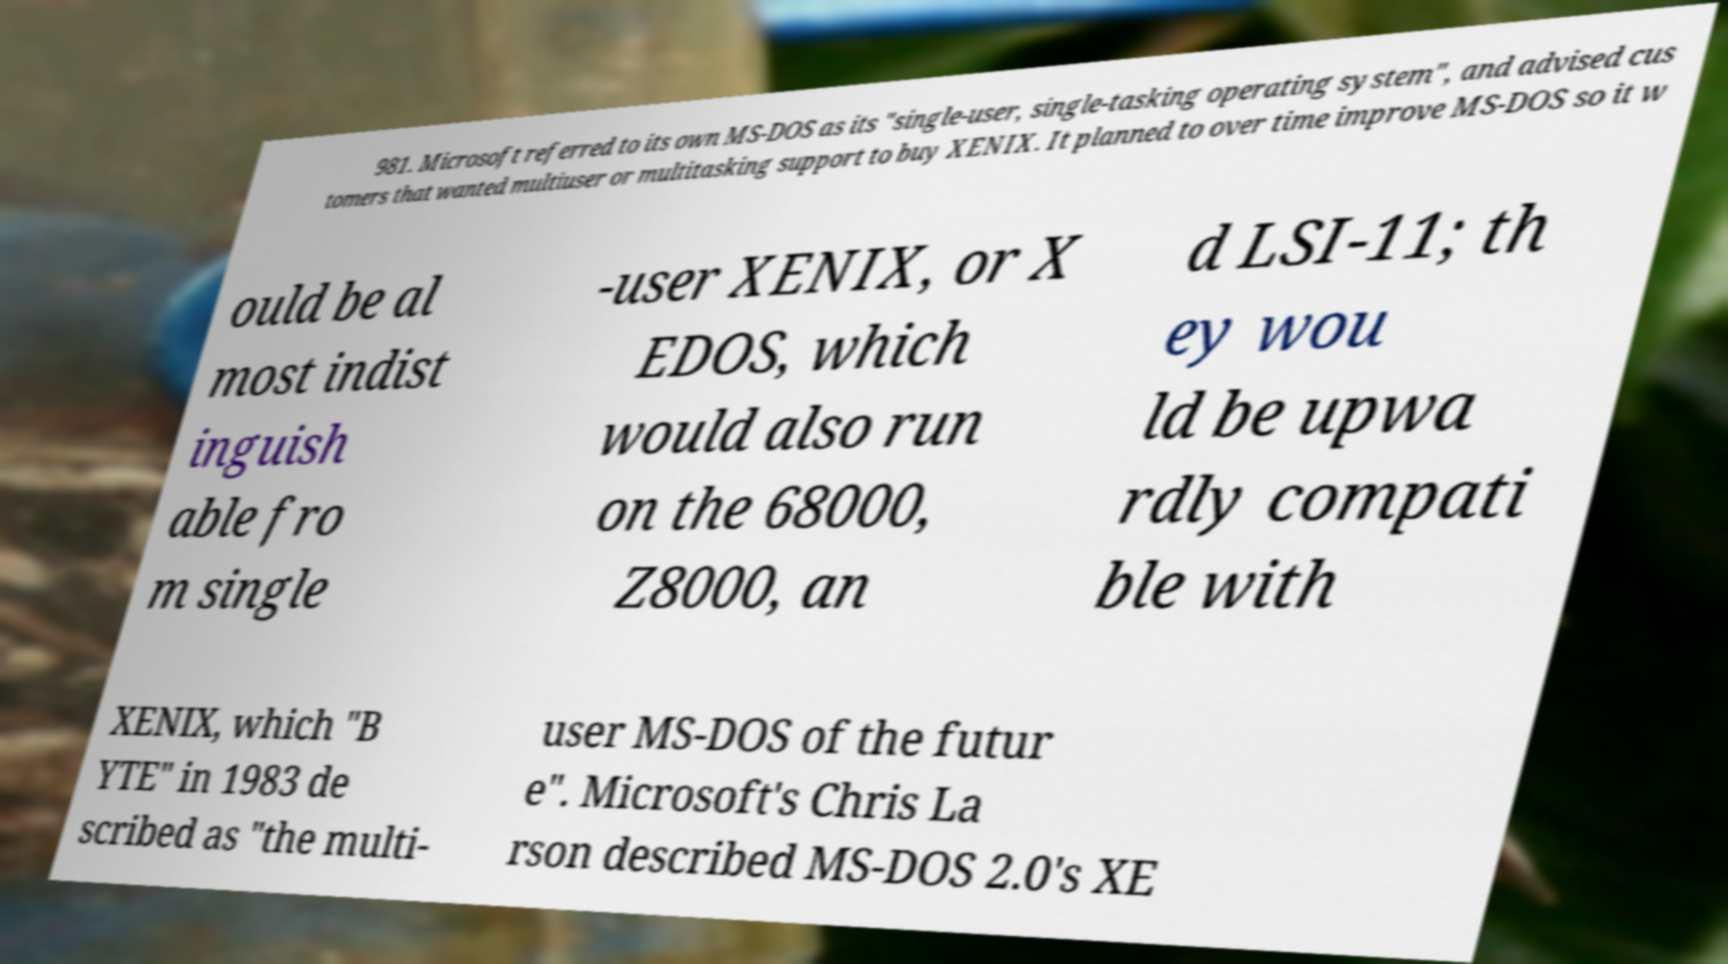There's text embedded in this image that I need extracted. Can you transcribe it verbatim? 981. Microsoft referred to its own MS-DOS as its "single-user, single-tasking operating system", and advised cus tomers that wanted multiuser or multitasking support to buy XENIX. It planned to over time improve MS-DOS so it w ould be al most indist inguish able fro m single -user XENIX, or X EDOS, which would also run on the 68000, Z8000, an d LSI-11; th ey wou ld be upwa rdly compati ble with XENIX, which "B YTE" in 1983 de scribed as "the multi- user MS-DOS of the futur e". Microsoft's Chris La rson described MS-DOS 2.0's XE 